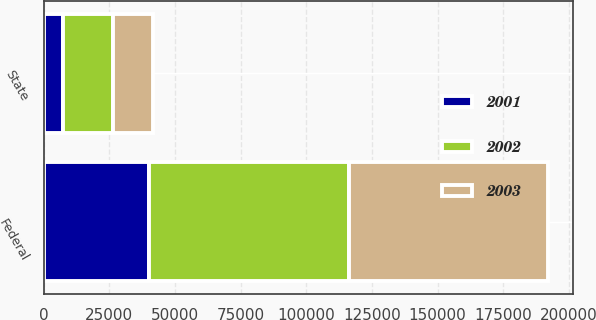<chart> <loc_0><loc_0><loc_500><loc_500><stacked_bar_chart><ecel><fcel>Federal<fcel>State<nl><fcel>2003<fcel>75817<fcel>15151<nl><fcel>2001<fcel>40094<fcel>7366<nl><fcel>2002<fcel>76084<fcel>19076<nl></chart> 